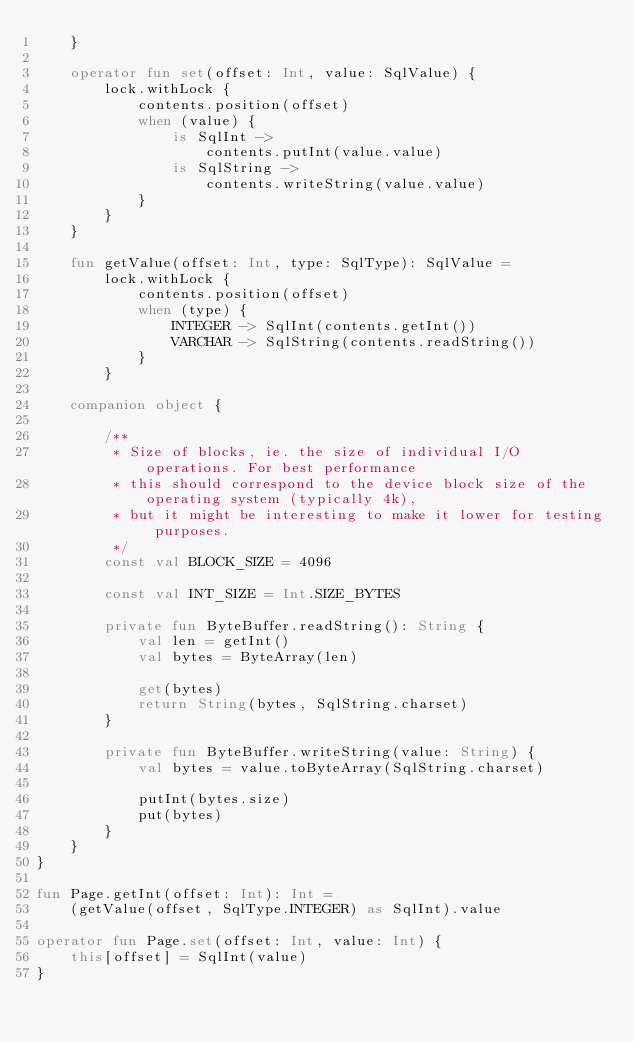Convert code to text. <code><loc_0><loc_0><loc_500><loc_500><_Kotlin_>    }

    operator fun set(offset: Int, value: SqlValue) {
        lock.withLock {
            contents.position(offset)
            when (value) {
                is SqlInt ->
                    contents.putInt(value.value)
                is SqlString ->
                    contents.writeString(value.value)
            }
        }
    }

    fun getValue(offset: Int, type: SqlType): SqlValue =
        lock.withLock {
            contents.position(offset)
            when (type) {
                INTEGER -> SqlInt(contents.getInt())
                VARCHAR -> SqlString(contents.readString())
            }
        }

    companion object {

        /**
         * Size of blocks, ie. the size of individual I/O operations. For best performance
         * this should correspond to the device block size of the operating system (typically 4k),
         * but it might be interesting to make it lower for testing purposes.
         */
        const val BLOCK_SIZE = 4096

        const val INT_SIZE = Int.SIZE_BYTES

        private fun ByteBuffer.readString(): String {
            val len = getInt()
            val bytes = ByteArray(len)

            get(bytes)
            return String(bytes, SqlString.charset)
        }

        private fun ByteBuffer.writeString(value: String) {
            val bytes = value.toByteArray(SqlString.charset)

            putInt(bytes.size)
            put(bytes)
        }
    }
}

fun Page.getInt(offset: Int): Int =
    (getValue(offset, SqlType.INTEGER) as SqlInt).value

operator fun Page.set(offset: Int, value: Int) {
    this[offset] = SqlInt(value)
}

</code> 